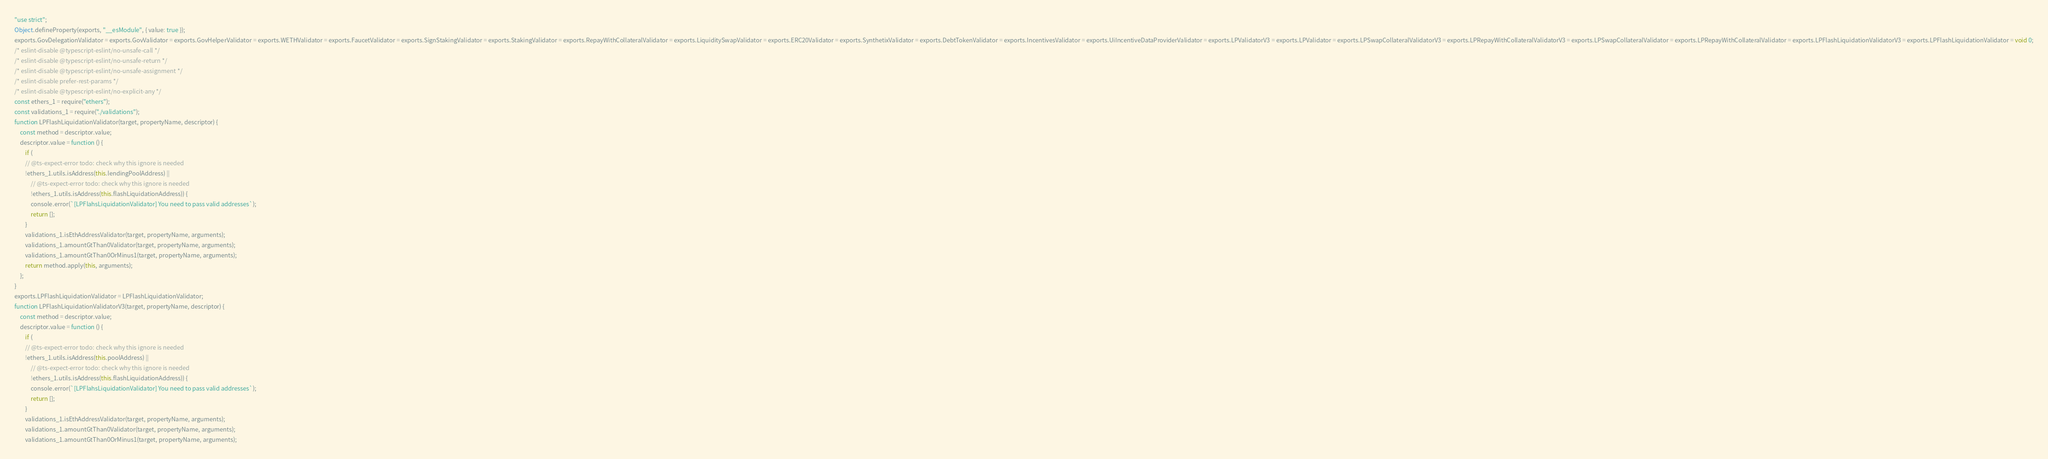<code> <loc_0><loc_0><loc_500><loc_500><_JavaScript_>"use strict";
Object.defineProperty(exports, "__esModule", { value: true });
exports.GovDelegationValidator = exports.GovValidator = exports.GovHelperValidator = exports.WETHValidator = exports.FaucetValidator = exports.SignStakingValidator = exports.StakingValidator = exports.RepayWithCollateralValidator = exports.LiquiditySwapValidator = exports.ERC20Validator = exports.SynthetixValidator = exports.DebtTokenValidator = exports.IncentivesValidator = exports.UiIncentiveDataProviderValidator = exports.LPValidatorV3 = exports.LPValidator = exports.LPSwapCollateralValidatorV3 = exports.LPRepayWithCollateralValidatorV3 = exports.LPSwapCollateralValidator = exports.LPRepayWithCollateralValidator = exports.LPFlashLiquidationValidatorV3 = exports.LPFlashLiquidationValidator = void 0;
/* eslint-disable @typescript-eslint/no-unsafe-call */
/* eslint-disable @typescript-eslint/no-unsafe-return */
/* eslint-disable @typescript-eslint/no-unsafe-assignment */
/* eslint-disable prefer-rest-params */
/* eslint-disable @typescript-eslint/no-explicit-any */
const ethers_1 = require("ethers");
const validations_1 = require("./validations");
function LPFlashLiquidationValidator(target, propertyName, descriptor) {
    const method = descriptor.value;
    descriptor.value = function () {
        if (
        // @ts-expect-error todo: check why this ignore is needed
        !ethers_1.utils.isAddress(this.lendingPoolAddress) ||
            // @ts-expect-error todo: check why this ignore is needed
            !ethers_1.utils.isAddress(this.flashLiquidationAddress)) {
            console.error(`[LPFlahsLiquidationValidator] You need to pass valid addresses`);
            return [];
        }
        validations_1.isEthAddressValidator(target, propertyName, arguments);
        validations_1.amountGtThan0Validator(target, propertyName, arguments);
        validations_1.amountGtThan0OrMinus1(target, propertyName, arguments);
        return method.apply(this, arguments);
    };
}
exports.LPFlashLiquidationValidator = LPFlashLiquidationValidator;
function LPFlashLiquidationValidatorV3(target, propertyName, descriptor) {
    const method = descriptor.value;
    descriptor.value = function () {
        if (
        // @ts-expect-error todo: check why this ignore is needed
        !ethers_1.utils.isAddress(this.poolAddress) ||
            // @ts-expect-error todo: check why this ignore is needed
            !ethers_1.utils.isAddress(this.flashLiquidationAddress)) {
            console.error(`[LPFlahsLiquidationValidator] You need to pass valid addresses`);
            return [];
        }
        validations_1.isEthAddressValidator(target, propertyName, arguments);
        validations_1.amountGtThan0Validator(target, propertyName, arguments);
        validations_1.amountGtThan0OrMinus1(target, propertyName, arguments);</code> 